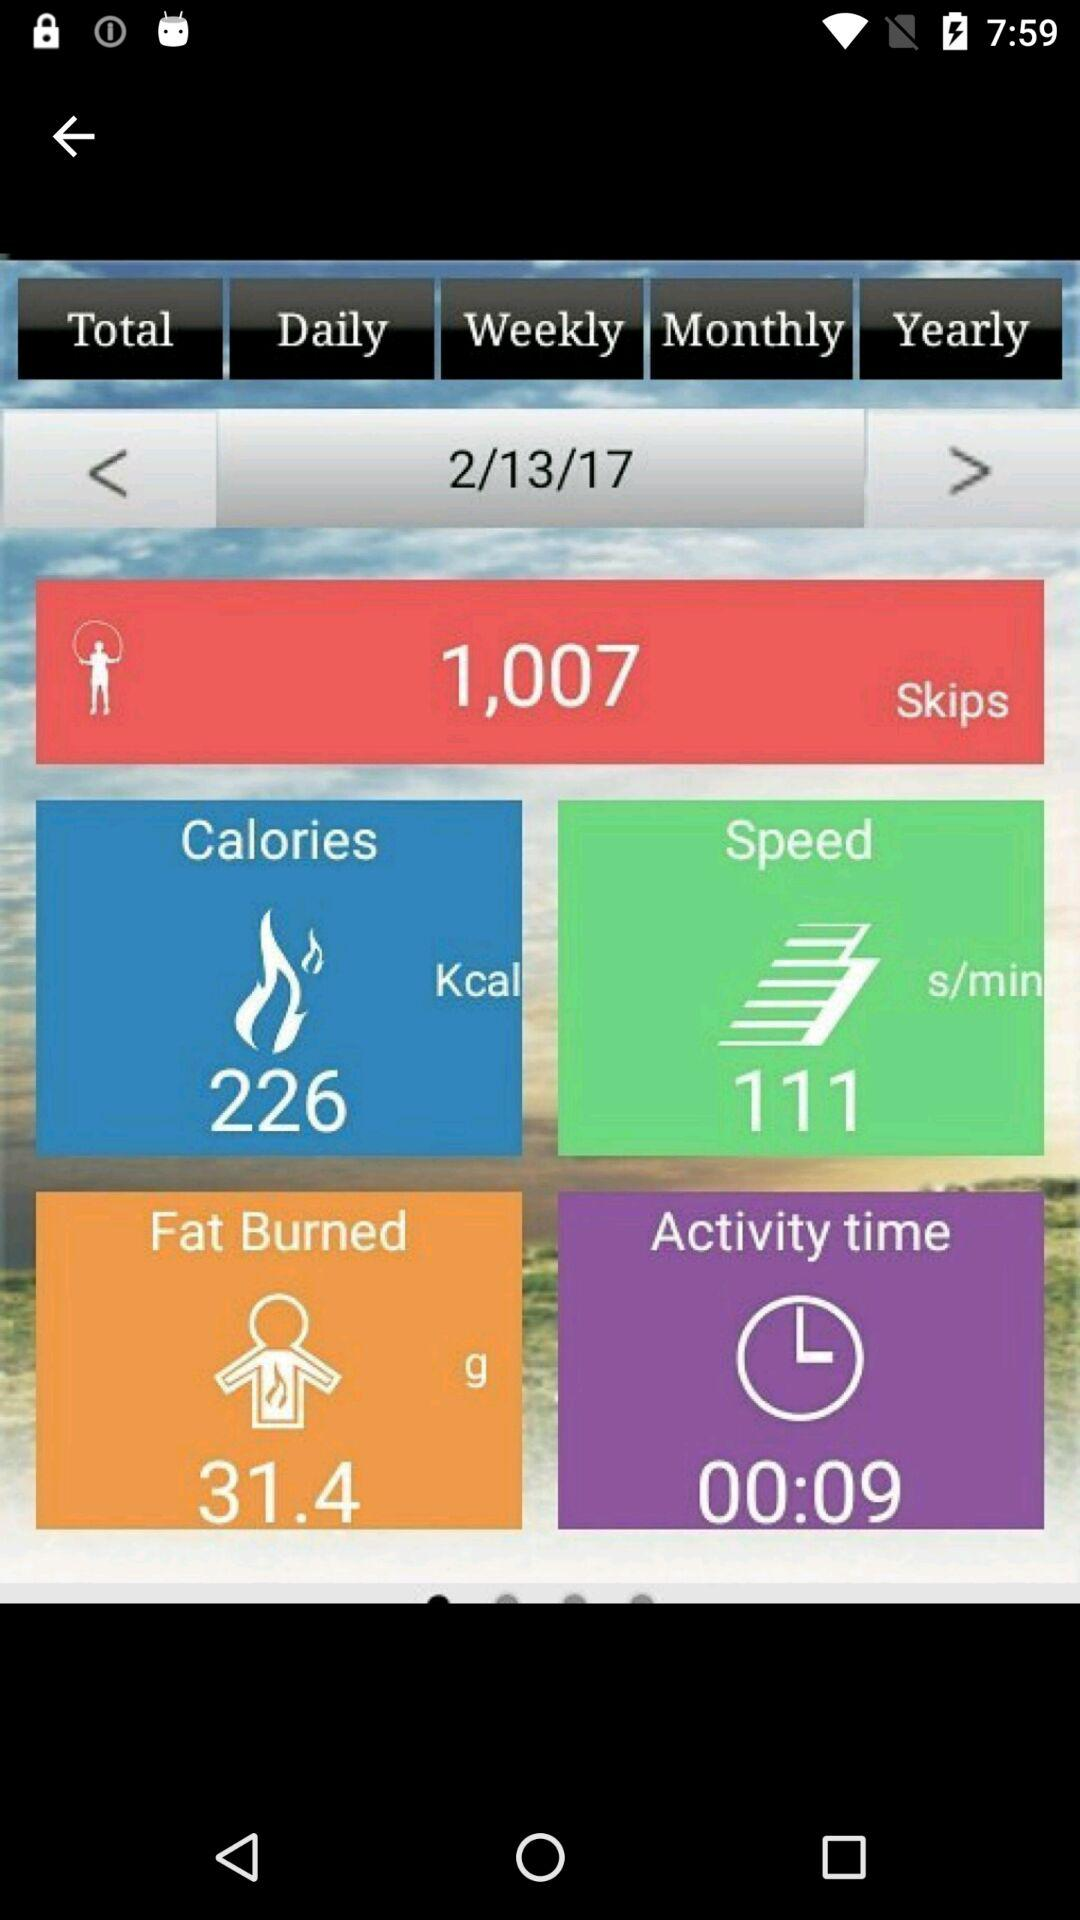What is the activity duration? The activity duration is 9 seconds. 